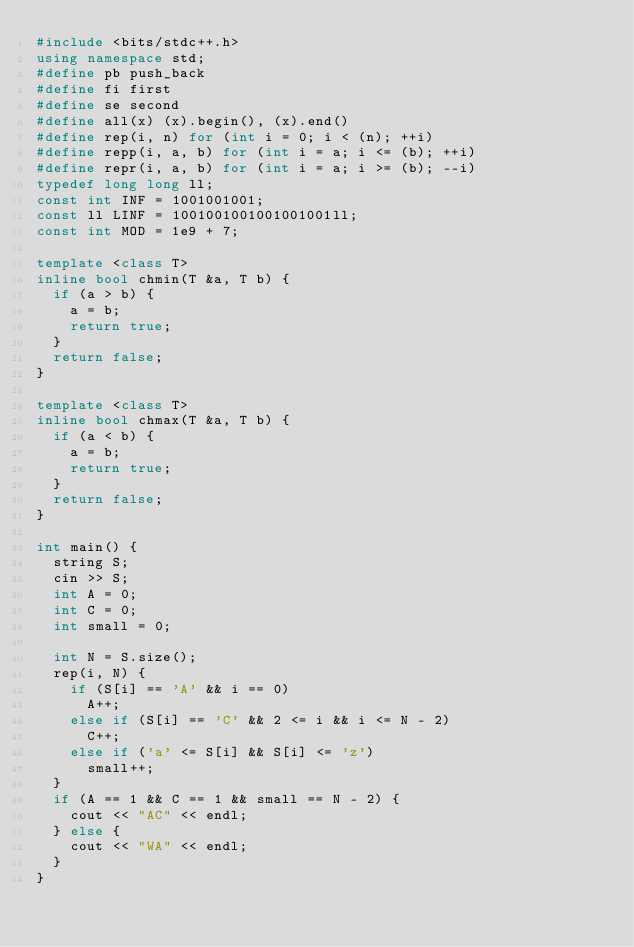Convert code to text. <code><loc_0><loc_0><loc_500><loc_500><_C++_>#include <bits/stdc++.h>
using namespace std;
#define pb push_back
#define fi first
#define se second
#define all(x) (x).begin(), (x).end()
#define rep(i, n) for (int i = 0; i < (n); ++i)
#define repp(i, a, b) for (int i = a; i <= (b); ++i)
#define repr(i, a, b) for (int i = a; i >= (b); --i)
typedef long long ll;
const int INF = 1001001001;
const ll LINF = 1001001001001001001ll;
const int MOD = 1e9 + 7;

template <class T>
inline bool chmin(T &a, T b) {
  if (a > b) {
    a = b;
    return true;
  }
  return false;
}

template <class T>
inline bool chmax(T &a, T b) {
  if (a < b) {
    a = b;
    return true;
  }
  return false;
}

int main() {
  string S;
  cin >> S;
  int A = 0;
  int C = 0;
  int small = 0;

  int N = S.size();
  rep(i, N) {
    if (S[i] == 'A' && i == 0)
      A++;
    else if (S[i] == 'C' && 2 <= i && i <= N - 2)
      C++;
    else if ('a' <= S[i] && S[i] <= 'z')
      small++;
  }
  if (A == 1 && C == 1 && small == N - 2) {
    cout << "AC" << endl;
  } else {
    cout << "WA" << endl;
  }
}</code> 